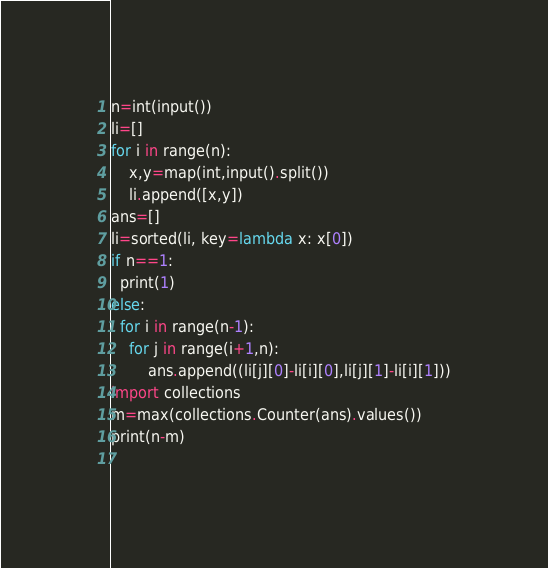Convert code to text. <code><loc_0><loc_0><loc_500><loc_500><_Python_>n=int(input())
li=[]
for i in range(n):
    x,y=map(int,input().split())
    li.append([x,y])
ans=[]
li=sorted(li, key=lambda x: x[0])
if n==1:
  print(1)
else:
  for i in range(n-1):
    for j in range(i+1,n):
        ans.append((li[j][0]-li[i][0],li[j][1]-li[i][1]))
import collections
m=max(collections.Counter(ans).values())
print(n-m)
  



</code> 